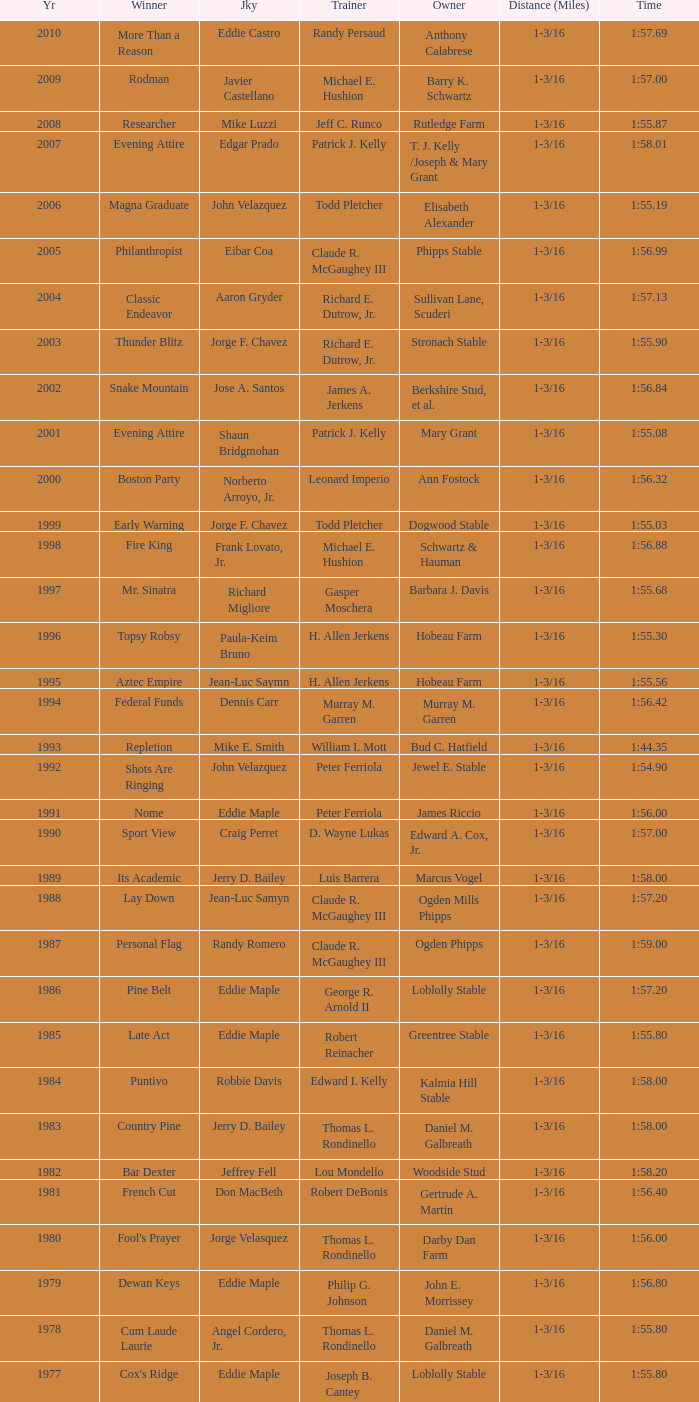Who was the jockey for the winning horse Helioptic? Paul Miller. Give me the full table as a dictionary. {'header': ['Yr', 'Winner', 'Jky', 'Trainer', 'Owner', 'Distance (Miles)', 'Time'], 'rows': [['2010', 'More Than a Reason', 'Eddie Castro', 'Randy Persaud', 'Anthony Calabrese', '1-3/16', '1:57.69'], ['2009', 'Rodman', 'Javier Castellano', 'Michael E. Hushion', 'Barry K. Schwartz', '1-3/16', '1:57.00'], ['2008', 'Researcher', 'Mike Luzzi', 'Jeff C. Runco', 'Rutledge Farm', '1-3/16', '1:55.87'], ['2007', 'Evening Attire', 'Edgar Prado', 'Patrick J. Kelly', 'T. J. Kelly /Joseph & Mary Grant', '1-3/16', '1:58.01'], ['2006', 'Magna Graduate', 'John Velazquez', 'Todd Pletcher', 'Elisabeth Alexander', '1-3/16', '1:55.19'], ['2005', 'Philanthropist', 'Eibar Coa', 'Claude R. McGaughey III', 'Phipps Stable', '1-3/16', '1:56.99'], ['2004', 'Classic Endeavor', 'Aaron Gryder', 'Richard E. Dutrow, Jr.', 'Sullivan Lane, Scuderi', '1-3/16', '1:57.13'], ['2003', 'Thunder Blitz', 'Jorge F. Chavez', 'Richard E. Dutrow, Jr.', 'Stronach Stable', '1-3/16', '1:55.90'], ['2002', 'Snake Mountain', 'Jose A. Santos', 'James A. Jerkens', 'Berkshire Stud, et al.', '1-3/16', '1:56.84'], ['2001', 'Evening Attire', 'Shaun Bridgmohan', 'Patrick J. Kelly', 'Mary Grant', '1-3/16', '1:55.08'], ['2000', 'Boston Party', 'Norberto Arroyo, Jr.', 'Leonard Imperio', 'Ann Fostock', '1-3/16', '1:56.32'], ['1999', 'Early Warning', 'Jorge F. Chavez', 'Todd Pletcher', 'Dogwood Stable', '1-3/16', '1:55.03'], ['1998', 'Fire King', 'Frank Lovato, Jr.', 'Michael E. Hushion', 'Schwartz & Hauman', '1-3/16', '1:56.88'], ['1997', 'Mr. Sinatra', 'Richard Migliore', 'Gasper Moschera', 'Barbara J. Davis', '1-3/16', '1:55.68'], ['1996', 'Topsy Robsy', 'Paula-Keim Bruno', 'H. Allen Jerkens', 'Hobeau Farm', '1-3/16', '1:55.30'], ['1995', 'Aztec Empire', 'Jean-Luc Saymn', 'H. Allen Jerkens', 'Hobeau Farm', '1-3/16', '1:55.56'], ['1994', 'Federal Funds', 'Dennis Carr', 'Murray M. Garren', 'Murray M. Garren', '1-3/16', '1:56.42'], ['1993', 'Repletion', 'Mike E. Smith', 'William I. Mott', 'Bud C. Hatfield', '1-3/16', '1:44.35'], ['1992', 'Shots Are Ringing', 'John Velazquez', 'Peter Ferriola', 'Jewel E. Stable', '1-3/16', '1:54.90'], ['1991', 'Nome', 'Eddie Maple', 'Peter Ferriola', 'James Riccio', '1-3/16', '1:56.00'], ['1990', 'Sport View', 'Craig Perret', 'D. Wayne Lukas', 'Edward A. Cox, Jr.', '1-3/16', '1:57.00'], ['1989', 'Its Academic', 'Jerry D. Bailey', 'Luis Barrera', 'Marcus Vogel', '1-3/16', '1:58.00'], ['1988', 'Lay Down', 'Jean-Luc Samyn', 'Claude R. McGaughey III', 'Ogden Mills Phipps', '1-3/16', '1:57.20'], ['1987', 'Personal Flag', 'Randy Romero', 'Claude R. McGaughey III', 'Ogden Phipps', '1-3/16', '1:59.00'], ['1986', 'Pine Belt', 'Eddie Maple', 'George R. Arnold II', 'Loblolly Stable', '1-3/16', '1:57.20'], ['1985', 'Late Act', 'Eddie Maple', 'Robert Reinacher', 'Greentree Stable', '1-3/16', '1:55.80'], ['1984', 'Puntivo', 'Robbie Davis', 'Edward I. Kelly', 'Kalmia Hill Stable', '1-3/16', '1:58.00'], ['1983', 'Country Pine', 'Jerry D. Bailey', 'Thomas L. Rondinello', 'Daniel M. Galbreath', '1-3/16', '1:58.00'], ['1982', 'Bar Dexter', 'Jeffrey Fell', 'Lou Mondello', 'Woodside Stud', '1-3/16', '1:58.20'], ['1981', 'French Cut', 'Don MacBeth', 'Robert DeBonis', 'Gertrude A. Martin', '1-3/16', '1:56.40'], ['1980', "Fool's Prayer", 'Jorge Velasquez', 'Thomas L. Rondinello', 'Darby Dan Farm', '1-3/16', '1:56.00'], ['1979', 'Dewan Keys', 'Eddie Maple', 'Philip G. Johnson', 'John E. Morrissey', '1-3/16', '1:56.80'], ['1978', 'Cum Laude Laurie', 'Angel Cordero, Jr.', 'Thomas L. Rondinello', 'Daniel M. Galbreath', '1-3/16', '1:55.80'], ['1977', "Cox's Ridge", 'Eddie Maple', 'Joseph B. Cantey', 'Loblolly Stable', '1-3/16', '1:55.80'], ['1976', "It's Freezing", 'Jacinto Vasquez', 'Anthony Basile', 'Bwamazon Farm', '1-3/16', '1:56.60'], ['1975', 'Hail The Pirates', 'Ron Turcotte', 'Thomas L. Rondinello', 'Daniel M. Galbreath', '1-3/16', '1:55.60'], ['1974', 'Free Hand', 'Jose Amy', 'Pancho Martin', 'Sigmund Sommer', '1-3/16', '1:55.00'], ['1973', 'True Knight', 'Angel Cordero, Jr.', 'Thomas L. Rondinello', 'Darby Dan Farm', '1-3/16', '1:55.00'], ['1972', 'Sunny And Mild', 'Michael Venezia', 'W. Preston King', 'Harry Rogosin', '1-3/16', '1:54.40'], ['1971', 'Red Reality', 'Jorge Velasquez', 'MacKenzie Miller', 'Cragwood Stables', '1-1/8', '1:49.60'], ['1970', 'Best Turn', 'Larry Adams', 'Reggie Cornell', 'Calumet Farm', '1-1/8', '1:50.00'], ['1969', 'Vif', 'Larry Adams', 'Clarence Meaux', 'Harvey Peltier', '1-1/8', '1:49.20'], ['1968', 'Irish Dude', 'Sandino Hernandez', 'Jack Bradley', 'Richard W. Taylor', '1-1/8', '1:49.60'], ['1967', 'Mr. Right', 'Heliodoro Gustines', 'Evan S. Jackson', 'Mrs. Peter Duchin', '1-1/8', '1:49.60'], ['1966', 'Amberoid', 'Walter Blum', 'Lucien Laurin', 'Reginald N. Webster', '1-1/8', '1:50.60'], ['1965', 'Prairie Schooner', 'Eddie Belmonte', 'James W. Smith', 'High Tide Stable', '1-1/8', '1:50.20'], ['1964', 'Third Martini', 'William Boland', 'H. Allen Jerkens', 'Hobeau Farm', '1-1/8', '1:50.60'], ['1963', 'Uppercut', 'Manuel Ycaza', 'Willard C. Freeman', 'William Harmonay', '1-1/8', '1:35.40'], ['1962', 'Grid Iron Hero', 'Manuel Ycaza', 'Laz Barrera', 'Emil Dolce', '1 mile', '1:34.00'], ['1961', 'Manassa Mauler', 'Braulio Baeza', 'Pancho Martin', 'Emil Dolce', '1 mile', '1:36.20'], ['1960', 'Cranberry Sauce', 'Heliodoro Gustines', 'not found', 'Elmendorf Farm', '1 mile', '1:36.20'], ['1959', 'Whitley', 'Eric Guerin', 'Max Hirsch', 'W. Arnold Hanger', '1 mile', '1:36.40'], ['1958', 'Oh Johnny', 'William Boland', 'Norman R. McLeod', 'Mrs. Wallace Gilroy', '1-1/16', '1:43.40'], ['1957', 'Bold Ruler', 'Eddie Arcaro', 'James E. Fitzsimmons', 'Wheatley Stable', '1-1/16', '1:42.80'], ['1956', 'Blessbull', 'Willie Lester', 'not found', 'Morris Sims', '1-1/16', '1:42.00'], ['1955', 'Fabulist', 'Ted Atkinson', 'William C. Winfrey', 'High Tide Stable', '1-1/16', '1:43.60'], ['1954', 'Find', 'Eric Guerin', 'William C. Winfrey', 'Alfred G. Vanderbilt II', '1-1/16', '1:44.00'], ['1953', 'Flaunt', 'S. Cole', 'Hubert W. Williams', 'Arnold Skjeveland', '1-1/16', '1:44.20'], ['1952', 'County Delight', 'Dave Gorman', 'James E. Ryan', 'Rokeby Stable', '1-1/16', '1:43.60'], ['1951', 'Sheilas Reward', 'Ovie Scurlock', 'Eugene Jacobs', 'Mrs. Louis Lazare', '1-1/16', '1:44.60'], ['1950', 'Three Rings', 'Hedley Woodhouse', 'Willie Knapp', 'Mrs. Evelyn L. Hopkins', '1-1/16', '1:44.60'], ['1949', 'Three Rings', 'Ted Atkinson', 'Willie Knapp', 'Mrs. Evelyn L. Hopkins', '1-1/16', '1:47.40'], ['1948', 'Knockdown', 'Ferrill Zufelt', 'Tom Smith', 'Maine Chance Farm', '1-1/16', '1:44.60'], ['1947', 'Gallorette', 'Job Dean Jessop', 'Edward A. Christmas', 'William L. Brann', '1-1/16', '1:45.40'], ['1946', 'Helioptic', 'Paul Miller', 'not found', 'William Goadby Loew', '1-1/16', '1:43.20'], ['1945', 'Olympic Zenith', 'Conn McCreary', 'Willie Booth', 'William G. Helis', '1-1/16', '1:45.60'], ['1944', 'First Fiddle', 'Johnny Longden', 'Edward Mulrenan', 'Mrs. Edward Mulrenan', '1-1/16', '1:44.20'], ['1943', 'The Rhymer', 'Conn McCreary', 'John M. Gaver, Sr.', 'Greentree Stable', '1-1/16', '1:45.00'], ['1942', 'Waller', 'Billie Thompson', 'A. G. Robertson', 'John C. Clark', '1-1/16', '1:44.00'], ['1941', 'Salford II', 'Don Meade', 'not found', 'Ralph B. Strassburger', '1-1/16', '1:44.20'], ['1940', 'He Did', 'Eddie Arcaro', 'J. Thomas Taylor', 'W. Arnold Hanger', '1-1/16', '1:43.20'], ['1939', 'Lovely Night', 'Johnny Longden', 'Henry McDaniel', 'Mrs. F. Ambrose Clark', '1 mile', '1:36.40'], ['1938', 'War Admiral', 'Charles Kurtsinger', 'George Conway', 'Glen Riddle Farm', '1 mile', '1:36.80'], ['1937', 'Snark', 'Johnny Longden', 'James E. Fitzsimmons', 'Wheatley Stable', '1 mile', '1:37.40'], ['1936', 'Good Gamble', 'Samuel Renick', 'Bud Stotler', 'Alfred G. Vanderbilt II', '1 mile', '1:37.20'], ['1935', 'King Saxon', 'Calvin Rainey', 'Charles Shaw', 'C. H. Knebelkamp', '1 mile', '1:37.20'], ['1934', 'Singing Wood', 'Robert Jones', 'James W. Healy', 'Liz Whitney', '1 mile', '1:38.60'], ['1933', 'Kerry Patch', 'Robert Wholey', 'Joseph A. Notter', 'Lee Rosenberg', '1 mile', '1:38.00'], ['1932', 'Halcyon', 'Hank Mills', 'T. J. Healey', 'C. V. Whitney', '1 mile', '1:38.00'], ['1931', 'Halcyon', 'G. Rose', 'T. J. Healey', 'C. V. Whitney', '1 mile', '1:38.40'], ['1930', 'Kildare', 'John Passero', 'Norman Tallman', 'Newtondale Stable', '1 mile', '1:38.60'], ['1929', 'Comstockery', 'Sidney Hebert', 'Thomas W. Murphy', 'Greentree Stable', '1 mile', '1:39.60'], ['1928', 'Kentucky II', 'George Schreiner', 'Max Hirsch', 'A. Charles Schwartz', '1 mile', '1:38.80'], ['1927', 'Light Carbine', 'James McCoy', 'M. J. Dunlevy', 'I. B. Humphreys', '1 mile', '1:36.80'], ['1926', 'Macaw', 'Linus McAtee', 'James G. Rowe, Sr.', 'Harry Payne Whitney', '1 mile', '1:37.00'], ['1925', 'Mad Play', 'Laverne Fator', 'Sam Hildreth', 'Rancocas Stable', '1 mile', '1:36.60'], ['1924', 'Mad Hatter', 'Earl Sande', 'Sam Hildreth', 'Rancocas Stable', '1 mile', '1:36.60'], ['1923', 'Zev', 'Earl Sande', 'Sam Hildreth', 'Rancocas Stable', '1 mile', '1:37.00'], ['1922', 'Grey Lag', 'Laverne Fator', 'Sam Hildreth', 'Rancocas Stable', '1 mile', '1:38.00'], ['1921', 'John P. Grier', 'Frank Keogh', 'James G. Rowe, Sr.', 'Harry Payne Whitney', '1 mile', '1:36.00'], ['1920', 'Cirrus', 'Lavelle Ensor', 'Sam Hildreth', 'Sam Hildreth', '1 mile', '1:38.00'], ['1919', 'Star Master', 'Merritt Buxton', 'Walter B. Jennings', 'A. Kingsley Macomber', '1 mile', '1:37.60'], ['1918', 'Roamer', 'Lawrence Lyke', 'A. J. Goldsborough', 'Andrew Miller', '1 mile', '1:36.60'], ['1917', 'Old Rosebud', 'Frank Robinson', 'Frank D. Weir', 'F. D. Weir & Hamilton C. Applegate', '1 mile', '1:37.60'], ['1916', 'Short Grass', 'Frank Keogh', 'not found', 'Emil Herz', '1 mile', '1:36.40'], ['1915', 'Roamer', 'James Butwell', 'A. J. Goldsborough', 'Andrew Miller', '1 mile', '1:39.20'], ['1914', 'Flying Fairy', 'Tommy Davies', 'J. Simon Healy', 'Edward B. Cassatt', '1 mile', '1:42.20'], ['1913', 'No Race', 'No Race', 'No Race', 'No Race', '1 mile', 'no race'], ['1912', 'No Race', 'No Race', 'No Race', 'No Race', '1 mile', 'no race'], ['1911', 'No Race', 'No Race', 'No Race', 'No Race', '1 mile', 'no race'], ['1910', 'Arasee', 'Buddy Glass', 'Andrew G. Blakely', 'Samuel Emery', '1 mile', '1:39.80'], ['1909', 'No Race', 'No Race', 'No Race', 'No Race', '1 mile', 'no race'], ['1908', 'Jack Atkin', 'Phil Musgrave', 'Herman R. Brandt', 'Barney Schreiber', '1 mile', '1:39.00'], ['1907', 'W. H. Carey', 'George Mountain', 'James Blute', 'Richard F. Carman', '1 mile', '1:40.00'], ['1906', "Ram's Horn", 'L. Perrine', 'W. S. "Jim" Williams', 'W. S. "Jim" Williams', '1 mile', '1:39.40'], ['1905', 'St. Valentine', 'William Crimmins', 'John Shields', 'Alexander Shields', '1 mile', '1:39.20'], ['1904', 'Rosetint', 'Thomas H. Burns', 'James Boden', 'John Boden', '1 mile', '1:39.20'], ['1903', 'Yellow Tail', 'Willie Shaw', 'H. E. Rowell', 'John Hackett', '1m 70yds', '1:45.20'], ['1902', 'Margravite', 'Otto Wonderly', 'not found', 'Charles Fleischmann Sons', '1m 70 yds', '1:46.00']]} 